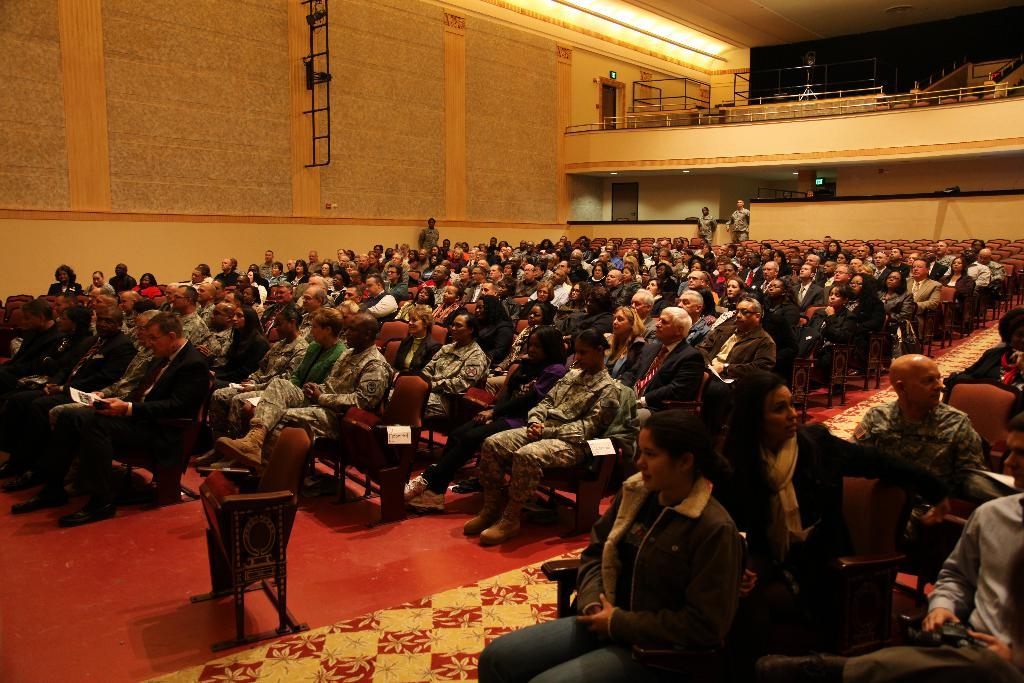How many people are in the image? There is a group of people in the image. What are some of the people in the image doing? Some people are sitting on chairs, while others are standing. What can be seen in the background of the image? There is a wall, a roof, rods, and some objects in the background of the image. What type of winter clothing can be seen on the family members in the image? There is no mention of family members or winter clothing in the image. The image features a group of people, but their clothing is not specified. 